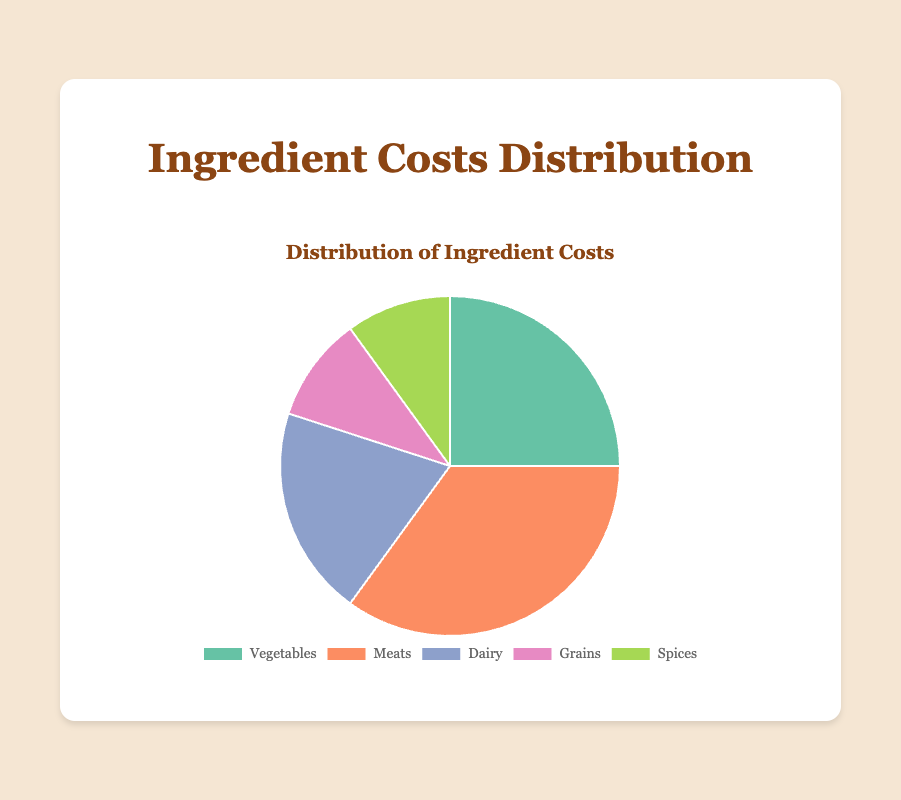What percentage of the total costs is spent on grains and spices combined? The pie chart shows that grains cost 10% and spices cost 10%. Adding these together, 10% + 10% = 20%.
Answer: 20% Which category has the highest cost percentage? By observing the pie chart, meats have the highest percentage which is 35%.
Answer: Meats How does the cost percentage of dairy compare to vegetables? The pie chart shows dairy at 20% and vegetables at 25%. Thus, the cost percentage of dairy is 5% lower than vegetables.
Answer: 5% lower What is the difference in cost percentage between the highest and lowest categories? The highest percentage is meats at 35%, and the lowest percentages are grains and spices, both at 10%. The difference is 35% - 10% = 25%.
Answer: 25% What portion of the pie chart is represented by dairy, grains, and spices combined? Dairy is 20%, grains are 10%, and spices are 10%. Adding these gives 20% + 10% + 10% = 40%.
Answer: 40% Which category has a lower cost percentage, vegetables or dairy? Vegetables have a cost percentage of 25%, and dairy has a cost percentage of 20%. Dairy is lower.
Answer: Dairy How much more is spent on meats compared to grains? Meats cost 35% and grains cost 10%. The difference is 35% - 10% = 25%.
Answer: 25% What color represents the meats category in the pie chart? Observing the chart, meats are represented by the orange color section.
Answer: Orange Between grains and spices, which category has a higher cost percentage? Both grains and spices have the same cost percentage of 10%.
Answer: Equal What is the average cost percentage for all categories? The percentages are: 25%, 35%, 20%, 10%, and 10%. Summing these: 25 + 35 + 20 + 10 + 10 = 100. Dividing by the number of categories (5), we get 100 / 5 = 20%.
Answer: 20% 